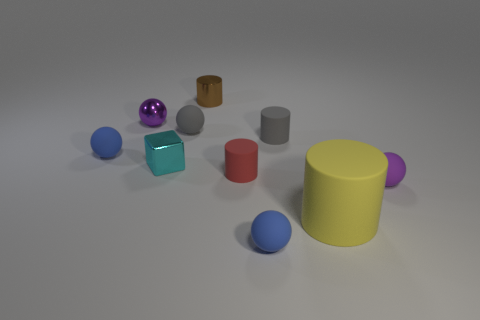Is there anything else that has the same size as the yellow rubber cylinder?
Make the answer very short. No. There is a tiny cylinder in front of the blue rubber sphere that is left of the brown thing; what is its color?
Offer a terse response. Red. How many red objects are matte spheres or tiny rubber things?
Your answer should be compact. 1. The rubber thing that is both behind the red thing and on the right side of the tiny red thing is what color?
Ensure brevity in your answer.  Gray. What number of tiny objects are either purple metal balls or purple objects?
Your answer should be compact. 2. There is a yellow thing that is the same shape as the tiny brown metallic object; what is its size?
Offer a very short reply. Large. What is the shape of the small red rubber thing?
Offer a terse response. Cylinder. Does the tiny red cylinder have the same material as the small purple sphere that is in front of the tiny red matte cylinder?
Your answer should be very brief. Yes. What number of metallic things are gray blocks or red cylinders?
Offer a terse response. 0. What size is the yellow cylinder in front of the tiny red object?
Provide a short and direct response. Large. 